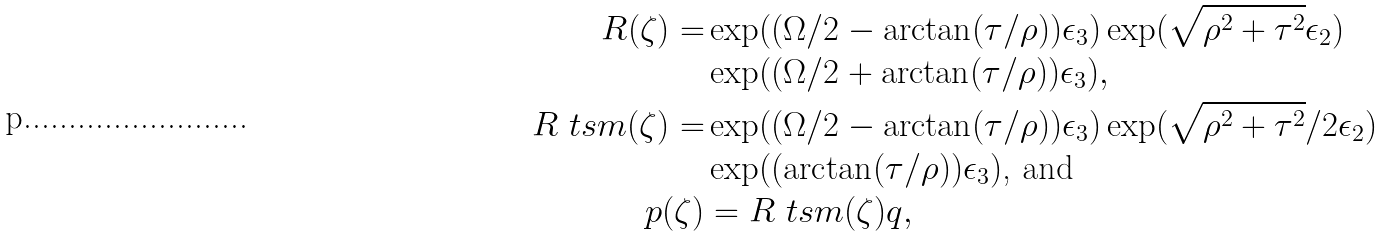<formula> <loc_0><loc_0><loc_500><loc_500>R ( \zeta ) = & \exp ( ( \Omega / 2 - \arctan ( \tau / \rho ) ) \epsilon _ { 3 } ) \exp ( \sqrt { \rho ^ { 2 } + \tau ^ { 2 } } \epsilon _ { 2 } ) \\ & \exp ( ( \Omega / 2 + \arctan ( \tau / \rho ) ) \epsilon _ { 3 } ) , \\ R \ t s { m } ( \zeta ) = & \exp ( ( \Omega / 2 - \arctan ( \tau / \rho ) ) \epsilon _ { 3 } ) \exp ( \sqrt { \rho ^ { 2 } + \tau ^ { 2 } } / 2 \epsilon _ { 2 } ) \\ & \exp ( ( \arctan ( \tau / \rho ) ) \epsilon _ { 3 } ) \text {, and} \\ p ( \zeta ) & = R \ t s { m } ( \zeta ) q ,</formula> 